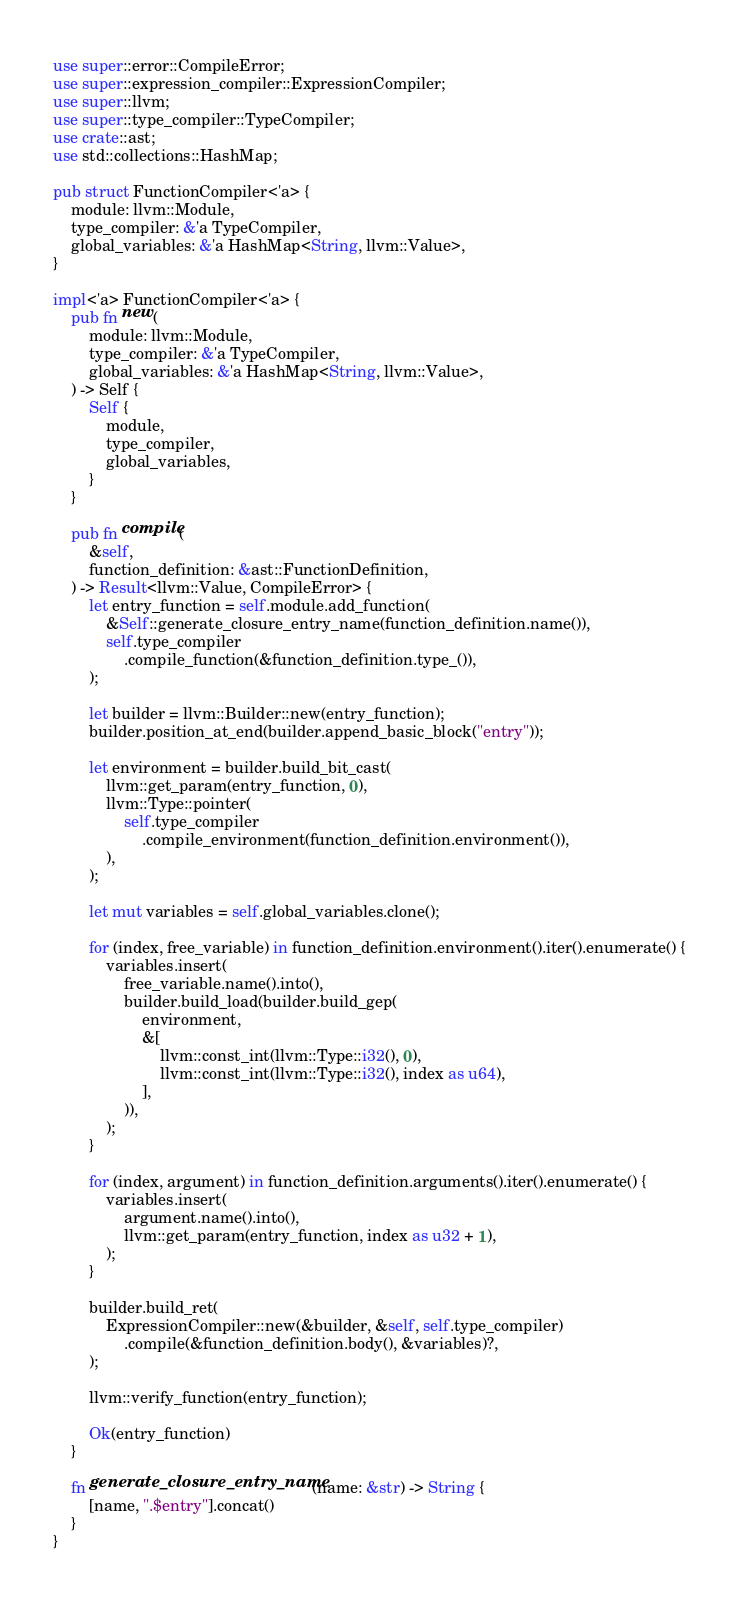<code> <loc_0><loc_0><loc_500><loc_500><_Rust_>use super::error::CompileError;
use super::expression_compiler::ExpressionCompiler;
use super::llvm;
use super::type_compiler::TypeCompiler;
use crate::ast;
use std::collections::HashMap;

pub struct FunctionCompiler<'a> {
    module: llvm::Module,
    type_compiler: &'a TypeCompiler,
    global_variables: &'a HashMap<String, llvm::Value>,
}

impl<'a> FunctionCompiler<'a> {
    pub fn new(
        module: llvm::Module,
        type_compiler: &'a TypeCompiler,
        global_variables: &'a HashMap<String, llvm::Value>,
    ) -> Self {
        Self {
            module,
            type_compiler,
            global_variables,
        }
    }

    pub fn compile(
        &self,
        function_definition: &ast::FunctionDefinition,
    ) -> Result<llvm::Value, CompileError> {
        let entry_function = self.module.add_function(
            &Self::generate_closure_entry_name(function_definition.name()),
            self.type_compiler
                .compile_function(&function_definition.type_()),
        );

        let builder = llvm::Builder::new(entry_function);
        builder.position_at_end(builder.append_basic_block("entry"));

        let environment = builder.build_bit_cast(
            llvm::get_param(entry_function, 0),
            llvm::Type::pointer(
                self.type_compiler
                    .compile_environment(function_definition.environment()),
            ),
        );

        let mut variables = self.global_variables.clone();

        for (index, free_variable) in function_definition.environment().iter().enumerate() {
            variables.insert(
                free_variable.name().into(),
                builder.build_load(builder.build_gep(
                    environment,
                    &[
                        llvm::const_int(llvm::Type::i32(), 0),
                        llvm::const_int(llvm::Type::i32(), index as u64),
                    ],
                )),
            );
        }

        for (index, argument) in function_definition.arguments().iter().enumerate() {
            variables.insert(
                argument.name().into(),
                llvm::get_param(entry_function, index as u32 + 1),
            );
        }

        builder.build_ret(
            ExpressionCompiler::new(&builder, &self, self.type_compiler)
                .compile(&function_definition.body(), &variables)?,
        );

        llvm::verify_function(entry_function);

        Ok(entry_function)
    }

    fn generate_closure_entry_name(name: &str) -> String {
        [name, ".$entry"].concat()
    }
}
</code> 